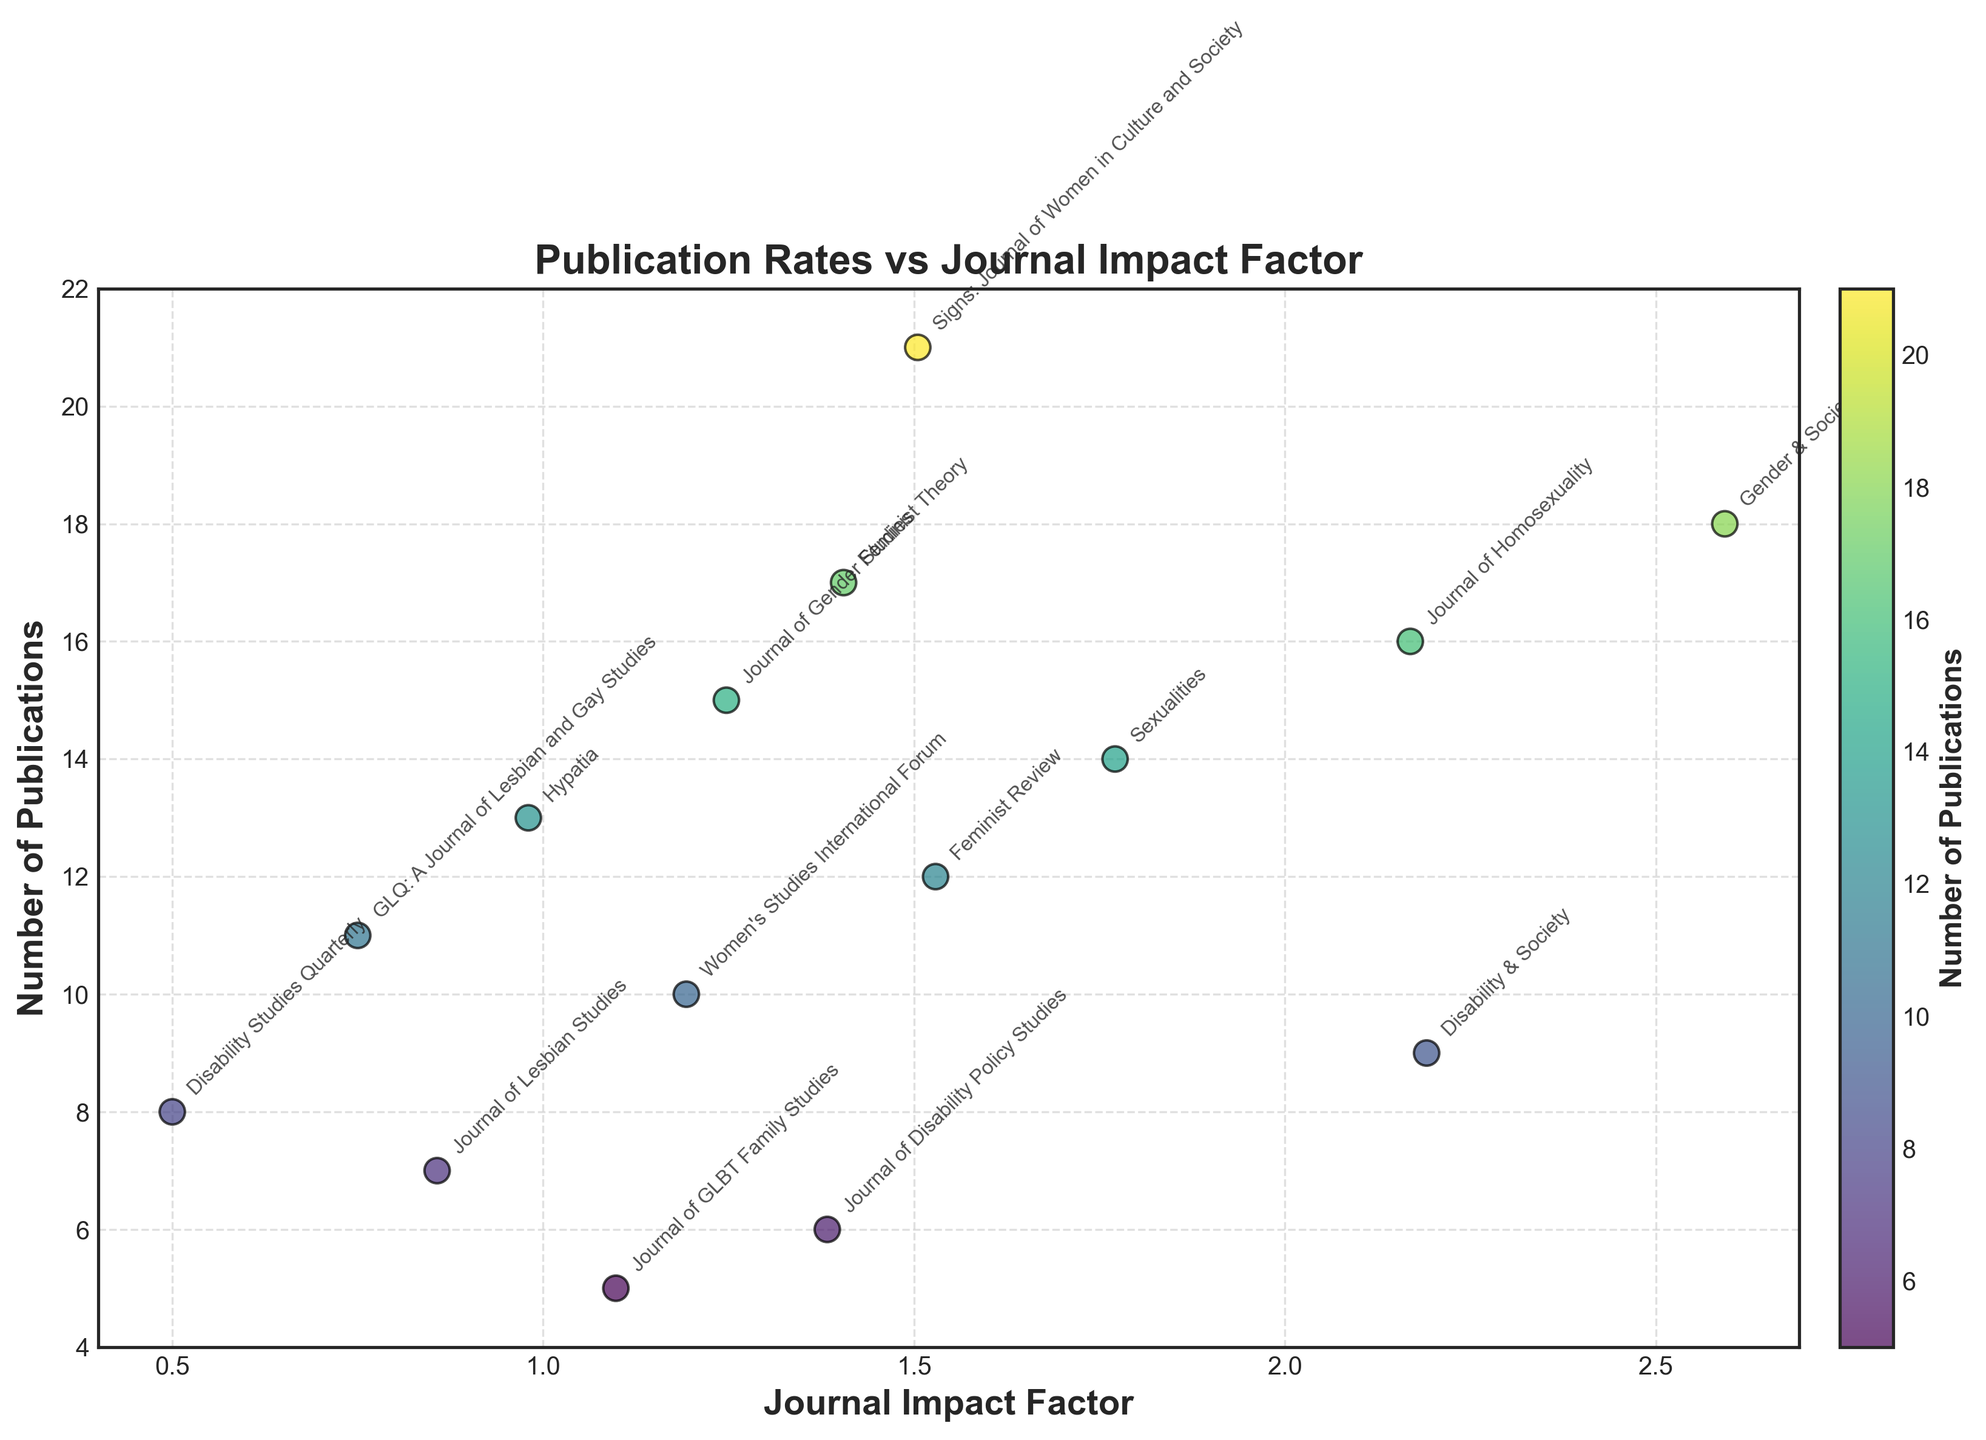What does the x-axis represent? The x-axis represents the journal impact factor, which is a measure of the yearly average number of citations to recent articles published in that journal.
Answer: Journal impact factor What journal has the highest impact factor? By looking at the x-axis values, the journal "Gender & Society" has the highest impact factor at 2.593.
Answer: Gender & Society How many publications does the journal 'Disability & Society' have? By locating "Disability & Society" on the plot, we see that it has 9 publications.
Answer: 9 Which journal has the lowest number of publications? The journal with the lowest number of publications can be identified by looking at the y-axis. "Journal of GLBT Family Studies" has 5 publications, which is the lowest.
Answer: Journal of GLBT Family Studies What is the general trend between impact factor and number of publications? By examining the overall distribution of points on the plot, it appears that there is no clear trend between impact factor and number of publications; they seem to be relatively scattered.
Answer: No clear trend Which journal has the most publications, and what is its impact factor? "Signs: Journal of Women in Culture and Society" has the most publications at 21, with an impact factor of 1.505.
Answer: Signs: Journal of Women in Culture and Society, 1.505 Are there any journals with an impact factor below 1? If so, name them. By scanning the x-axis for values below 1, the journals "GLQ: A Journal of Lesbian and Gay Studies" (0.750), "Hypatia" (0.980), and "Disability Studies Quarterly" (0.500) have impact factors below 1.
Answer: GLQ: A Journal of Lesbian and Gay Studies, Hypatia, Disability Studies Quarterly What is the total number of publications from journals with an impact factor above 2? The journals with impact factors above 2 are "Gender & Society" (18 publications), "Disability & Society" (9 publications), and "Journal of Homosexuality" (16 publications). Adding these gives 18 + 9 + 16 = 43.
Answer: 43 Which journal entries have the same impact factor? "Journal of Homosexuality" and "Disability & Society" both have an impact factor of 2.191.
Answer: Journal of Homosexuality and Disability & Society Which journal has the highest publication with the lowest impact factor? "Signs: Journal of Women in Culture and Society" has the highest number of publications (21) among journals with lower impact factors compared to the highest impact factor journal.
Answer: Signs: Journal of Women in Culture and Society 